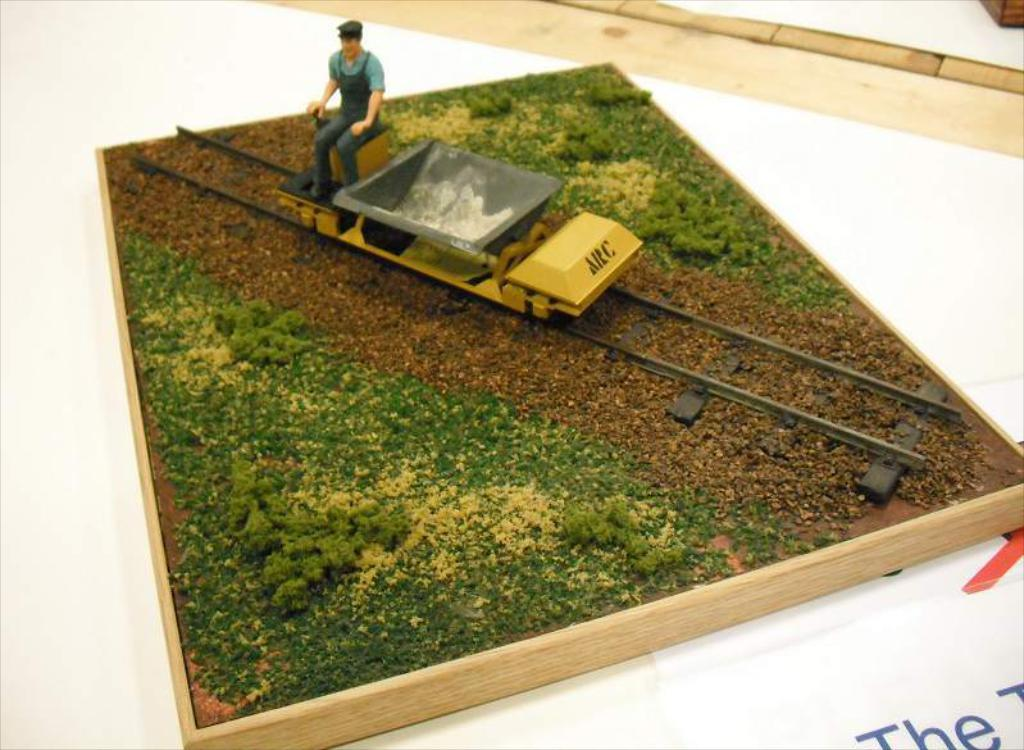What type of objects can be seen in the image? There are toys in the image. What type of natural environment is visible in the image? There is grass in the image. What material is used for the wooden object in the image? The wooden object in the image is made of wood. What is the color of the surface at the bottom of the image? The white surface at the bottom of the image is white. What is written on the white surface? There is some text on the white surface. What type of objects can be seen at the top of the image? There are wooden objects visible at the top of the image. What color is present at the top of the image? The color white is present at the top of the image. How many loaves of bread are visible in the image? There is no bread present in the image. What type of copy machine is used to duplicate the wooden objects in the image? There is no copy machine present in the image, and the wooden objects are not being duplicated. 